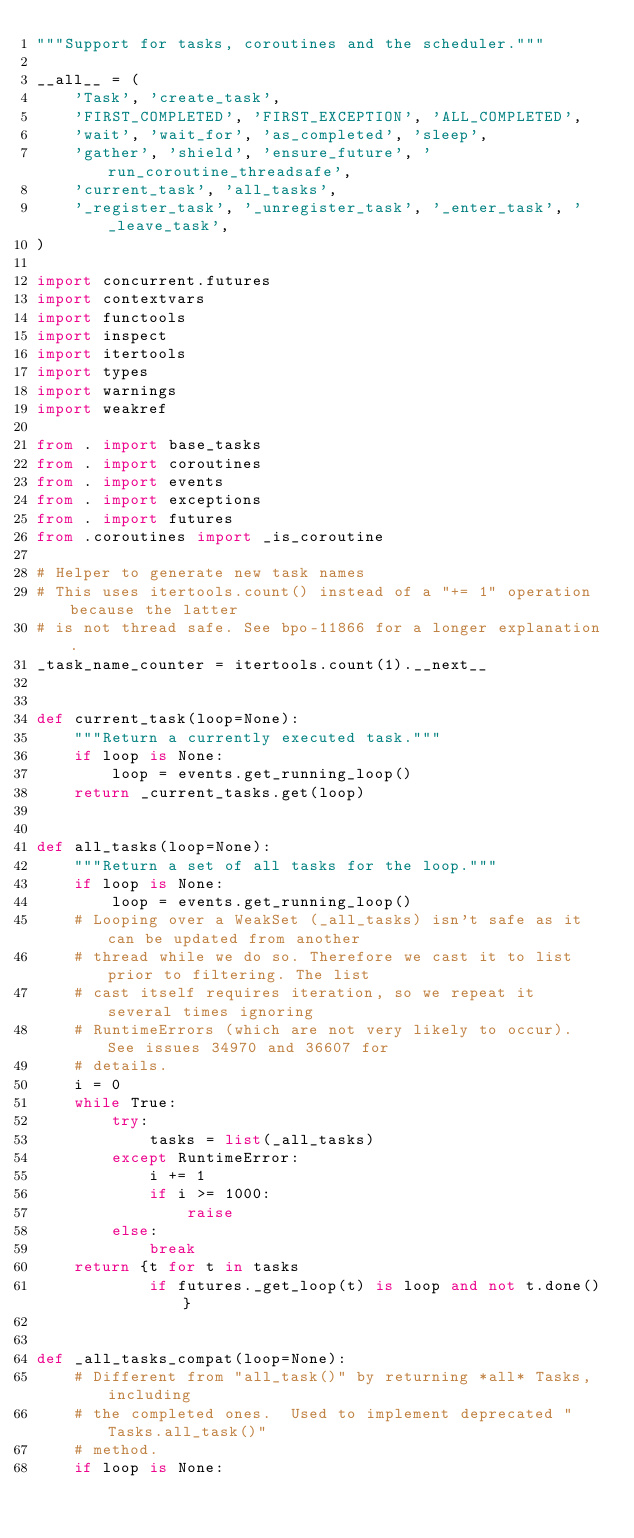Convert code to text. <code><loc_0><loc_0><loc_500><loc_500><_Python_>"""Support for tasks, coroutines and the scheduler."""

__all__ = (
    'Task', 'create_task',
    'FIRST_COMPLETED', 'FIRST_EXCEPTION', 'ALL_COMPLETED',
    'wait', 'wait_for', 'as_completed', 'sleep',
    'gather', 'shield', 'ensure_future', 'run_coroutine_threadsafe',
    'current_task', 'all_tasks',
    '_register_task', '_unregister_task', '_enter_task', '_leave_task',
)

import concurrent.futures
import contextvars
import functools
import inspect
import itertools
import types
import warnings
import weakref

from . import base_tasks
from . import coroutines
from . import events
from . import exceptions
from . import futures
from .coroutines import _is_coroutine

# Helper to generate new task names
# This uses itertools.count() instead of a "+= 1" operation because the latter
# is not thread safe. See bpo-11866 for a longer explanation.
_task_name_counter = itertools.count(1).__next__


def current_task(loop=None):
    """Return a currently executed task."""
    if loop is None:
        loop = events.get_running_loop()
    return _current_tasks.get(loop)


def all_tasks(loop=None):
    """Return a set of all tasks for the loop."""
    if loop is None:
        loop = events.get_running_loop()
    # Looping over a WeakSet (_all_tasks) isn't safe as it can be updated from another
    # thread while we do so. Therefore we cast it to list prior to filtering. The list
    # cast itself requires iteration, so we repeat it several times ignoring
    # RuntimeErrors (which are not very likely to occur). See issues 34970 and 36607 for
    # details.
    i = 0
    while True:
        try:
            tasks = list(_all_tasks)
        except RuntimeError:
            i += 1
            if i >= 1000:
                raise
        else:
            break
    return {t for t in tasks
            if futures._get_loop(t) is loop and not t.done()}


def _all_tasks_compat(loop=None):
    # Different from "all_task()" by returning *all* Tasks, including
    # the completed ones.  Used to implement deprecated "Tasks.all_task()"
    # method.
    if loop is None:</code> 